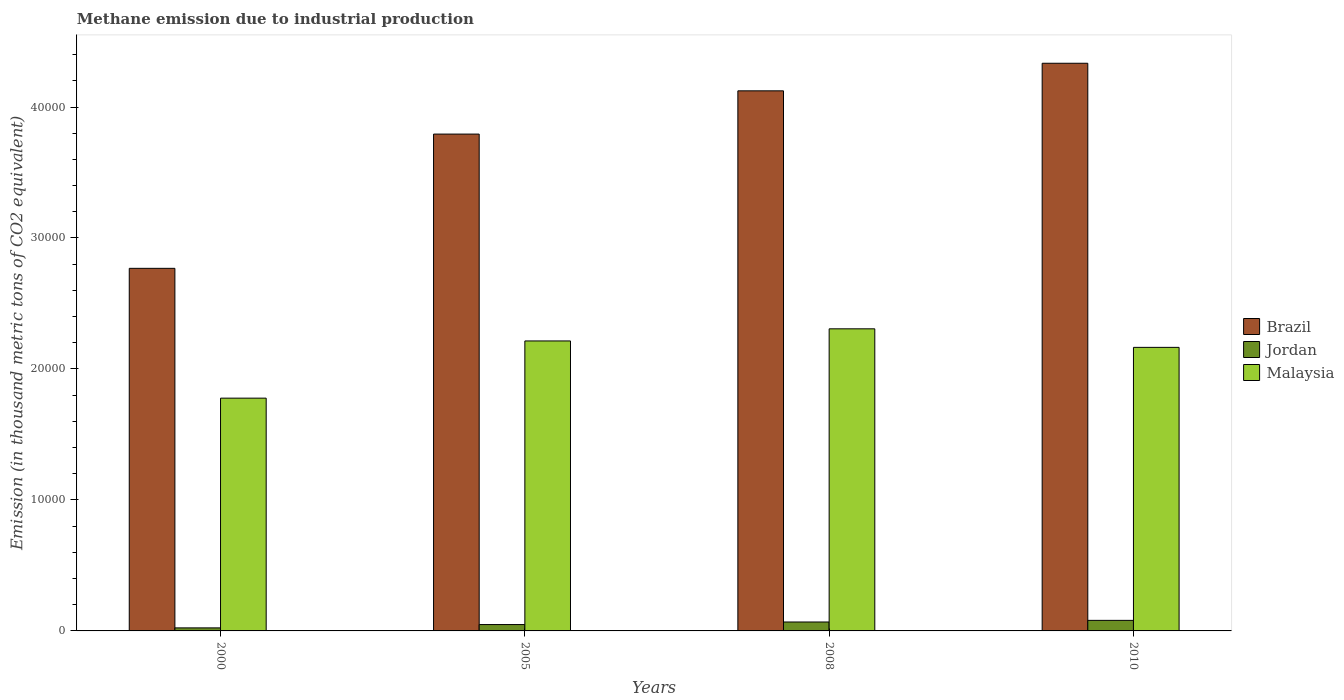How many different coloured bars are there?
Your response must be concise. 3. How many groups of bars are there?
Give a very brief answer. 4. In how many cases, is the number of bars for a given year not equal to the number of legend labels?
Your response must be concise. 0. What is the amount of methane emitted in Malaysia in 2005?
Offer a very short reply. 2.21e+04. Across all years, what is the maximum amount of methane emitted in Jordan?
Offer a terse response. 805.4. Across all years, what is the minimum amount of methane emitted in Malaysia?
Offer a very short reply. 1.78e+04. In which year was the amount of methane emitted in Brazil maximum?
Your answer should be very brief. 2010. In which year was the amount of methane emitted in Brazil minimum?
Offer a terse response. 2000. What is the total amount of methane emitted in Malaysia in the graph?
Provide a short and direct response. 8.46e+04. What is the difference between the amount of methane emitted in Brazil in 2000 and that in 2005?
Make the answer very short. -1.02e+04. What is the difference between the amount of methane emitted in Jordan in 2000 and the amount of methane emitted in Malaysia in 2005?
Offer a terse response. -2.19e+04. What is the average amount of methane emitted in Malaysia per year?
Provide a short and direct response. 2.12e+04. In the year 2008, what is the difference between the amount of methane emitted in Jordan and amount of methane emitted in Brazil?
Provide a succinct answer. -4.06e+04. In how many years, is the amount of methane emitted in Brazil greater than 26000 thousand metric tons?
Offer a terse response. 4. What is the ratio of the amount of methane emitted in Brazil in 2005 to that in 2010?
Make the answer very short. 0.88. What is the difference between the highest and the second highest amount of methane emitted in Brazil?
Your answer should be very brief. 2105.2. What is the difference between the highest and the lowest amount of methane emitted in Jordan?
Provide a short and direct response. 574. What does the 3rd bar from the left in 2005 represents?
Offer a terse response. Malaysia. What does the 1st bar from the right in 2010 represents?
Offer a terse response. Malaysia. Is it the case that in every year, the sum of the amount of methane emitted in Jordan and amount of methane emitted in Brazil is greater than the amount of methane emitted in Malaysia?
Provide a short and direct response. Yes. Are the values on the major ticks of Y-axis written in scientific E-notation?
Make the answer very short. No. Does the graph contain any zero values?
Provide a short and direct response. No. Where does the legend appear in the graph?
Ensure brevity in your answer.  Center right. How are the legend labels stacked?
Make the answer very short. Vertical. What is the title of the graph?
Your response must be concise. Methane emission due to industrial production. What is the label or title of the X-axis?
Keep it short and to the point. Years. What is the label or title of the Y-axis?
Make the answer very short. Emission (in thousand metric tons of CO2 equivalent). What is the Emission (in thousand metric tons of CO2 equivalent) of Brazil in 2000?
Provide a succinct answer. 2.77e+04. What is the Emission (in thousand metric tons of CO2 equivalent) in Jordan in 2000?
Your answer should be compact. 231.4. What is the Emission (in thousand metric tons of CO2 equivalent) in Malaysia in 2000?
Ensure brevity in your answer.  1.78e+04. What is the Emission (in thousand metric tons of CO2 equivalent) in Brazil in 2005?
Offer a very short reply. 3.79e+04. What is the Emission (in thousand metric tons of CO2 equivalent) in Jordan in 2005?
Your response must be concise. 486.3. What is the Emission (in thousand metric tons of CO2 equivalent) in Malaysia in 2005?
Your answer should be compact. 2.21e+04. What is the Emission (in thousand metric tons of CO2 equivalent) of Brazil in 2008?
Offer a very short reply. 4.12e+04. What is the Emission (in thousand metric tons of CO2 equivalent) in Jordan in 2008?
Provide a succinct answer. 681.7. What is the Emission (in thousand metric tons of CO2 equivalent) of Malaysia in 2008?
Your answer should be very brief. 2.31e+04. What is the Emission (in thousand metric tons of CO2 equivalent) of Brazil in 2010?
Ensure brevity in your answer.  4.33e+04. What is the Emission (in thousand metric tons of CO2 equivalent) in Jordan in 2010?
Give a very brief answer. 805.4. What is the Emission (in thousand metric tons of CO2 equivalent) in Malaysia in 2010?
Your answer should be compact. 2.16e+04. Across all years, what is the maximum Emission (in thousand metric tons of CO2 equivalent) in Brazil?
Provide a short and direct response. 4.33e+04. Across all years, what is the maximum Emission (in thousand metric tons of CO2 equivalent) of Jordan?
Give a very brief answer. 805.4. Across all years, what is the maximum Emission (in thousand metric tons of CO2 equivalent) in Malaysia?
Provide a short and direct response. 2.31e+04. Across all years, what is the minimum Emission (in thousand metric tons of CO2 equivalent) of Brazil?
Your answer should be very brief. 2.77e+04. Across all years, what is the minimum Emission (in thousand metric tons of CO2 equivalent) in Jordan?
Your answer should be very brief. 231.4. Across all years, what is the minimum Emission (in thousand metric tons of CO2 equivalent) of Malaysia?
Your response must be concise. 1.78e+04. What is the total Emission (in thousand metric tons of CO2 equivalent) in Brazil in the graph?
Offer a very short reply. 1.50e+05. What is the total Emission (in thousand metric tons of CO2 equivalent) in Jordan in the graph?
Give a very brief answer. 2204.8. What is the total Emission (in thousand metric tons of CO2 equivalent) in Malaysia in the graph?
Ensure brevity in your answer.  8.46e+04. What is the difference between the Emission (in thousand metric tons of CO2 equivalent) of Brazil in 2000 and that in 2005?
Your answer should be very brief. -1.02e+04. What is the difference between the Emission (in thousand metric tons of CO2 equivalent) of Jordan in 2000 and that in 2005?
Your response must be concise. -254.9. What is the difference between the Emission (in thousand metric tons of CO2 equivalent) in Malaysia in 2000 and that in 2005?
Offer a terse response. -4367.4. What is the difference between the Emission (in thousand metric tons of CO2 equivalent) in Brazil in 2000 and that in 2008?
Keep it short and to the point. -1.36e+04. What is the difference between the Emission (in thousand metric tons of CO2 equivalent) of Jordan in 2000 and that in 2008?
Your answer should be compact. -450.3. What is the difference between the Emission (in thousand metric tons of CO2 equivalent) of Malaysia in 2000 and that in 2008?
Your response must be concise. -5293.2. What is the difference between the Emission (in thousand metric tons of CO2 equivalent) of Brazil in 2000 and that in 2010?
Provide a succinct answer. -1.57e+04. What is the difference between the Emission (in thousand metric tons of CO2 equivalent) of Jordan in 2000 and that in 2010?
Give a very brief answer. -574. What is the difference between the Emission (in thousand metric tons of CO2 equivalent) in Malaysia in 2000 and that in 2010?
Your response must be concise. -3877.5. What is the difference between the Emission (in thousand metric tons of CO2 equivalent) in Brazil in 2005 and that in 2008?
Offer a terse response. -3302.1. What is the difference between the Emission (in thousand metric tons of CO2 equivalent) of Jordan in 2005 and that in 2008?
Offer a very short reply. -195.4. What is the difference between the Emission (in thousand metric tons of CO2 equivalent) of Malaysia in 2005 and that in 2008?
Keep it short and to the point. -925.8. What is the difference between the Emission (in thousand metric tons of CO2 equivalent) of Brazil in 2005 and that in 2010?
Make the answer very short. -5407.3. What is the difference between the Emission (in thousand metric tons of CO2 equivalent) in Jordan in 2005 and that in 2010?
Provide a succinct answer. -319.1. What is the difference between the Emission (in thousand metric tons of CO2 equivalent) in Malaysia in 2005 and that in 2010?
Provide a succinct answer. 489.9. What is the difference between the Emission (in thousand metric tons of CO2 equivalent) of Brazil in 2008 and that in 2010?
Keep it short and to the point. -2105.2. What is the difference between the Emission (in thousand metric tons of CO2 equivalent) of Jordan in 2008 and that in 2010?
Provide a succinct answer. -123.7. What is the difference between the Emission (in thousand metric tons of CO2 equivalent) of Malaysia in 2008 and that in 2010?
Make the answer very short. 1415.7. What is the difference between the Emission (in thousand metric tons of CO2 equivalent) in Brazil in 2000 and the Emission (in thousand metric tons of CO2 equivalent) in Jordan in 2005?
Give a very brief answer. 2.72e+04. What is the difference between the Emission (in thousand metric tons of CO2 equivalent) of Brazil in 2000 and the Emission (in thousand metric tons of CO2 equivalent) of Malaysia in 2005?
Give a very brief answer. 5544.5. What is the difference between the Emission (in thousand metric tons of CO2 equivalent) in Jordan in 2000 and the Emission (in thousand metric tons of CO2 equivalent) in Malaysia in 2005?
Give a very brief answer. -2.19e+04. What is the difference between the Emission (in thousand metric tons of CO2 equivalent) in Brazil in 2000 and the Emission (in thousand metric tons of CO2 equivalent) in Jordan in 2008?
Your answer should be very brief. 2.70e+04. What is the difference between the Emission (in thousand metric tons of CO2 equivalent) in Brazil in 2000 and the Emission (in thousand metric tons of CO2 equivalent) in Malaysia in 2008?
Keep it short and to the point. 4618.7. What is the difference between the Emission (in thousand metric tons of CO2 equivalent) in Jordan in 2000 and the Emission (in thousand metric tons of CO2 equivalent) in Malaysia in 2008?
Ensure brevity in your answer.  -2.28e+04. What is the difference between the Emission (in thousand metric tons of CO2 equivalent) in Brazil in 2000 and the Emission (in thousand metric tons of CO2 equivalent) in Jordan in 2010?
Your response must be concise. 2.69e+04. What is the difference between the Emission (in thousand metric tons of CO2 equivalent) in Brazil in 2000 and the Emission (in thousand metric tons of CO2 equivalent) in Malaysia in 2010?
Offer a terse response. 6034.4. What is the difference between the Emission (in thousand metric tons of CO2 equivalent) in Jordan in 2000 and the Emission (in thousand metric tons of CO2 equivalent) in Malaysia in 2010?
Provide a short and direct response. -2.14e+04. What is the difference between the Emission (in thousand metric tons of CO2 equivalent) of Brazil in 2005 and the Emission (in thousand metric tons of CO2 equivalent) of Jordan in 2008?
Keep it short and to the point. 3.73e+04. What is the difference between the Emission (in thousand metric tons of CO2 equivalent) of Brazil in 2005 and the Emission (in thousand metric tons of CO2 equivalent) of Malaysia in 2008?
Give a very brief answer. 1.49e+04. What is the difference between the Emission (in thousand metric tons of CO2 equivalent) in Jordan in 2005 and the Emission (in thousand metric tons of CO2 equivalent) in Malaysia in 2008?
Your answer should be compact. -2.26e+04. What is the difference between the Emission (in thousand metric tons of CO2 equivalent) of Brazil in 2005 and the Emission (in thousand metric tons of CO2 equivalent) of Jordan in 2010?
Your answer should be very brief. 3.71e+04. What is the difference between the Emission (in thousand metric tons of CO2 equivalent) in Brazil in 2005 and the Emission (in thousand metric tons of CO2 equivalent) in Malaysia in 2010?
Provide a short and direct response. 1.63e+04. What is the difference between the Emission (in thousand metric tons of CO2 equivalent) of Jordan in 2005 and the Emission (in thousand metric tons of CO2 equivalent) of Malaysia in 2010?
Give a very brief answer. -2.12e+04. What is the difference between the Emission (in thousand metric tons of CO2 equivalent) of Brazil in 2008 and the Emission (in thousand metric tons of CO2 equivalent) of Jordan in 2010?
Offer a terse response. 4.04e+04. What is the difference between the Emission (in thousand metric tons of CO2 equivalent) of Brazil in 2008 and the Emission (in thousand metric tons of CO2 equivalent) of Malaysia in 2010?
Provide a succinct answer. 1.96e+04. What is the difference between the Emission (in thousand metric tons of CO2 equivalent) of Jordan in 2008 and the Emission (in thousand metric tons of CO2 equivalent) of Malaysia in 2010?
Offer a very short reply. -2.10e+04. What is the average Emission (in thousand metric tons of CO2 equivalent) in Brazil per year?
Your response must be concise. 3.75e+04. What is the average Emission (in thousand metric tons of CO2 equivalent) of Jordan per year?
Your answer should be very brief. 551.2. What is the average Emission (in thousand metric tons of CO2 equivalent) in Malaysia per year?
Your response must be concise. 2.12e+04. In the year 2000, what is the difference between the Emission (in thousand metric tons of CO2 equivalent) of Brazil and Emission (in thousand metric tons of CO2 equivalent) of Jordan?
Your answer should be compact. 2.75e+04. In the year 2000, what is the difference between the Emission (in thousand metric tons of CO2 equivalent) of Brazil and Emission (in thousand metric tons of CO2 equivalent) of Malaysia?
Keep it short and to the point. 9911.9. In the year 2000, what is the difference between the Emission (in thousand metric tons of CO2 equivalent) of Jordan and Emission (in thousand metric tons of CO2 equivalent) of Malaysia?
Your response must be concise. -1.75e+04. In the year 2005, what is the difference between the Emission (in thousand metric tons of CO2 equivalent) of Brazil and Emission (in thousand metric tons of CO2 equivalent) of Jordan?
Give a very brief answer. 3.74e+04. In the year 2005, what is the difference between the Emission (in thousand metric tons of CO2 equivalent) of Brazil and Emission (in thousand metric tons of CO2 equivalent) of Malaysia?
Your answer should be very brief. 1.58e+04. In the year 2005, what is the difference between the Emission (in thousand metric tons of CO2 equivalent) of Jordan and Emission (in thousand metric tons of CO2 equivalent) of Malaysia?
Give a very brief answer. -2.17e+04. In the year 2008, what is the difference between the Emission (in thousand metric tons of CO2 equivalent) of Brazil and Emission (in thousand metric tons of CO2 equivalent) of Jordan?
Your response must be concise. 4.06e+04. In the year 2008, what is the difference between the Emission (in thousand metric tons of CO2 equivalent) of Brazil and Emission (in thousand metric tons of CO2 equivalent) of Malaysia?
Make the answer very short. 1.82e+04. In the year 2008, what is the difference between the Emission (in thousand metric tons of CO2 equivalent) of Jordan and Emission (in thousand metric tons of CO2 equivalent) of Malaysia?
Ensure brevity in your answer.  -2.24e+04. In the year 2010, what is the difference between the Emission (in thousand metric tons of CO2 equivalent) of Brazil and Emission (in thousand metric tons of CO2 equivalent) of Jordan?
Your answer should be very brief. 4.25e+04. In the year 2010, what is the difference between the Emission (in thousand metric tons of CO2 equivalent) in Brazil and Emission (in thousand metric tons of CO2 equivalent) in Malaysia?
Your answer should be very brief. 2.17e+04. In the year 2010, what is the difference between the Emission (in thousand metric tons of CO2 equivalent) of Jordan and Emission (in thousand metric tons of CO2 equivalent) of Malaysia?
Your answer should be very brief. -2.08e+04. What is the ratio of the Emission (in thousand metric tons of CO2 equivalent) of Brazil in 2000 to that in 2005?
Provide a succinct answer. 0.73. What is the ratio of the Emission (in thousand metric tons of CO2 equivalent) in Jordan in 2000 to that in 2005?
Ensure brevity in your answer.  0.48. What is the ratio of the Emission (in thousand metric tons of CO2 equivalent) in Malaysia in 2000 to that in 2005?
Give a very brief answer. 0.8. What is the ratio of the Emission (in thousand metric tons of CO2 equivalent) of Brazil in 2000 to that in 2008?
Provide a succinct answer. 0.67. What is the ratio of the Emission (in thousand metric tons of CO2 equivalent) in Jordan in 2000 to that in 2008?
Your response must be concise. 0.34. What is the ratio of the Emission (in thousand metric tons of CO2 equivalent) in Malaysia in 2000 to that in 2008?
Offer a terse response. 0.77. What is the ratio of the Emission (in thousand metric tons of CO2 equivalent) of Brazil in 2000 to that in 2010?
Make the answer very short. 0.64. What is the ratio of the Emission (in thousand metric tons of CO2 equivalent) in Jordan in 2000 to that in 2010?
Keep it short and to the point. 0.29. What is the ratio of the Emission (in thousand metric tons of CO2 equivalent) in Malaysia in 2000 to that in 2010?
Give a very brief answer. 0.82. What is the ratio of the Emission (in thousand metric tons of CO2 equivalent) of Brazil in 2005 to that in 2008?
Give a very brief answer. 0.92. What is the ratio of the Emission (in thousand metric tons of CO2 equivalent) of Jordan in 2005 to that in 2008?
Your answer should be compact. 0.71. What is the ratio of the Emission (in thousand metric tons of CO2 equivalent) in Malaysia in 2005 to that in 2008?
Provide a short and direct response. 0.96. What is the ratio of the Emission (in thousand metric tons of CO2 equivalent) of Brazil in 2005 to that in 2010?
Make the answer very short. 0.88. What is the ratio of the Emission (in thousand metric tons of CO2 equivalent) of Jordan in 2005 to that in 2010?
Provide a succinct answer. 0.6. What is the ratio of the Emission (in thousand metric tons of CO2 equivalent) in Malaysia in 2005 to that in 2010?
Your response must be concise. 1.02. What is the ratio of the Emission (in thousand metric tons of CO2 equivalent) of Brazil in 2008 to that in 2010?
Make the answer very short. 0.95. What is the ratio of the Emission (in thousand metric tons of CO2 equivalent) of Jordan in 2008 to that in 2010?
Keep it short and to the point. 0.85. What is the ratio of the Emission (in thousand metric tons of CO2 equivalent) of Malaysia in 2008 to that in 2010?
Offer a terse response. 1.07. What is the difference between the highest and the second highest Emission (in thousand metric tons of CO2 equivalent) in Brazil?
Ensure brevity in your answer.  2105.2. What is the difference between the highest and the second highest Emission (in thousand metric tons of CO2 equivalent) in Jordan?
Offer a very short reply. 123.7. What is the difference between the highest and the second highest Emission (in thousand metric tons of CO2 equivalent) of Malaysia?
Ensure brevity in your answer.  925.8. What is the difference between the highest and the lowest Emission (in thousand metric tons of CO2 equivalent) of Brazil?
Your response must be concise. 1.57e+04. What is the difference between the highest and the lowest Emission (in thousand metric tons of CO2 equivalent) in Jordan?
Your answer should be compact. 574. What is the difference between the highest and the lowest Emission (in thousand metric tons of CO2 equivalent) in Malaysia?
Give a very brief answer. 5293.2. 